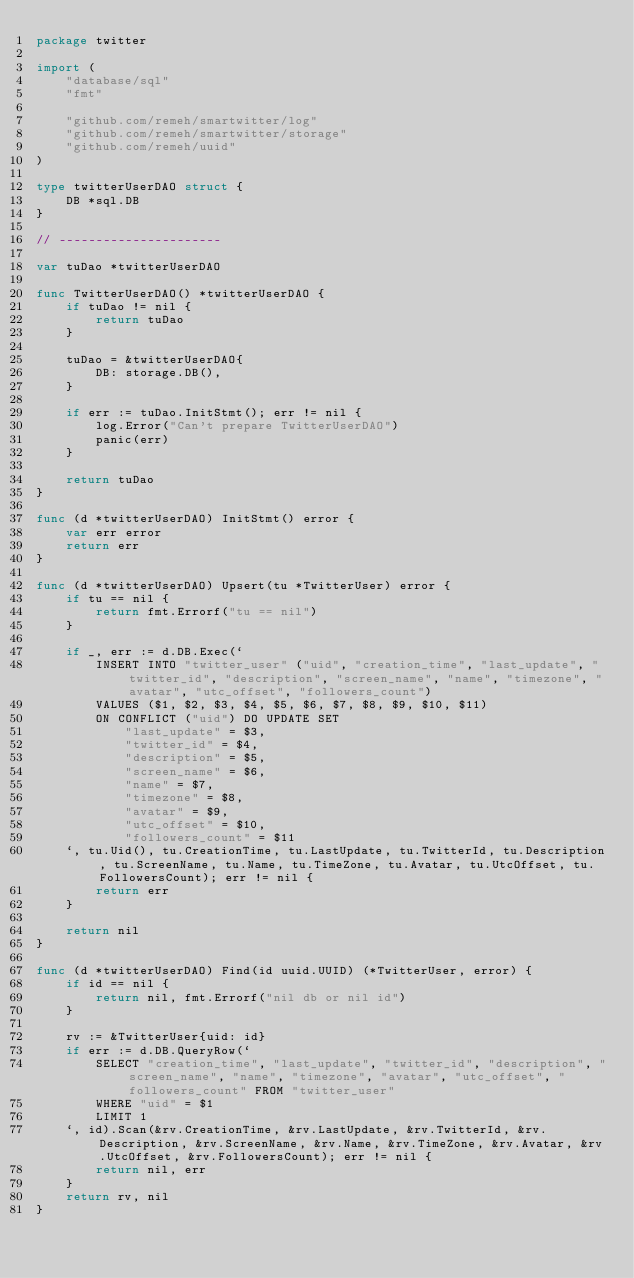Convert code to text. <code><loc_0><loc_0><loc_500><loc_500><_Go_>package twitter

import (
	"database/sql"
	"fmt"

	"github.com/remeh/smartwitter/log"
	"github.com/remeh/smartwitter/storage"
	"github.com/remeh/uuid"
)

type twitterUserDAO struct {
	DB *sql.DB
}

// ----------------------

var tuDao *twitterUserDAO

func TwitterUserDAO() *twitterUserDAO {
	if tuDao != nil {
		return tuDao
	}

	tuDao = &twitterUserDAO{
		DB: storage.DB(),
	}

	if err := tuDao.InitStmt(); err != nil {
		log.Error("Can't prepare TwitterUserDAO")
		panic(err)
	}

	return tuDao
}

func (d *twitterUserDAO) InitStmt() error {
	var err error
	return err
}

func (d *twitterUserDAO) Upsert(tu *TwitterUser) error {
	if tu == nil {
		return fmt.Errorf("tu == nil")
	}

	if _, err := d.DB.Exec(`
		INSERT INTO "twitter_user" ("uid", "creation_time", "last_update", "twitter_id", "description", "screen_name", "name", "timezone", "avatar", "utc_offset", "followers_count")
		VALUES ($1, $2, $3, $4, $5, $6, $7, $8, $9, $10, $11)
		ON CONFLICT ("uid") DO UPDATE SET
			"last_update" = $3,
			"twitter_id" = $4,
			"description" = $5,
			"screen_name" = $6,
			"name" = $7,
			"timezone" = $8,
			"avatar" = $9,
			"utc_offset" = $10,
			"followers_count" = $11
	`, tu.Uid(), tu.CreationTime, tu.LastUpdate, tu.TwitterId, tu.Description, tu.ScreenName, tu.Name, tu.TimeZone, tu.Avatar, tu.UtcOffset, tu.FollowersCount); err != nil {
		return err
	}

	return nil
}

func (d *twitterUserDAO) Find(id uuid.UUID) (*TwitterUser, error) {
	if id == nil {
		return nil, fmt.Errorf("nil db or nil id")
	}

	rv := &TwitterUser{uid: id}
	if err := d.DB.QueryRow(`
		SELECT "creation_time", "last_update", "twitter_id", "description", "screen_name", "name", "timezone", "avatar", "utc_offset", "followers_count" FROM "twitter_user"
		WHERE "uid" = $1
		LIMIT 1
	`, id).Scan(&rv.CreationTime, &rv.LastUpdate, &rv.TwitterId, &rv.Description, &rv.ScreenName, &rv.Name, &rv.TimeZone, &rv.Avatar, &rv.UtcOffset, &rv.FollowersCount); err != nil {
		return nil, err
	}
	return rv, nil
}
</code> 